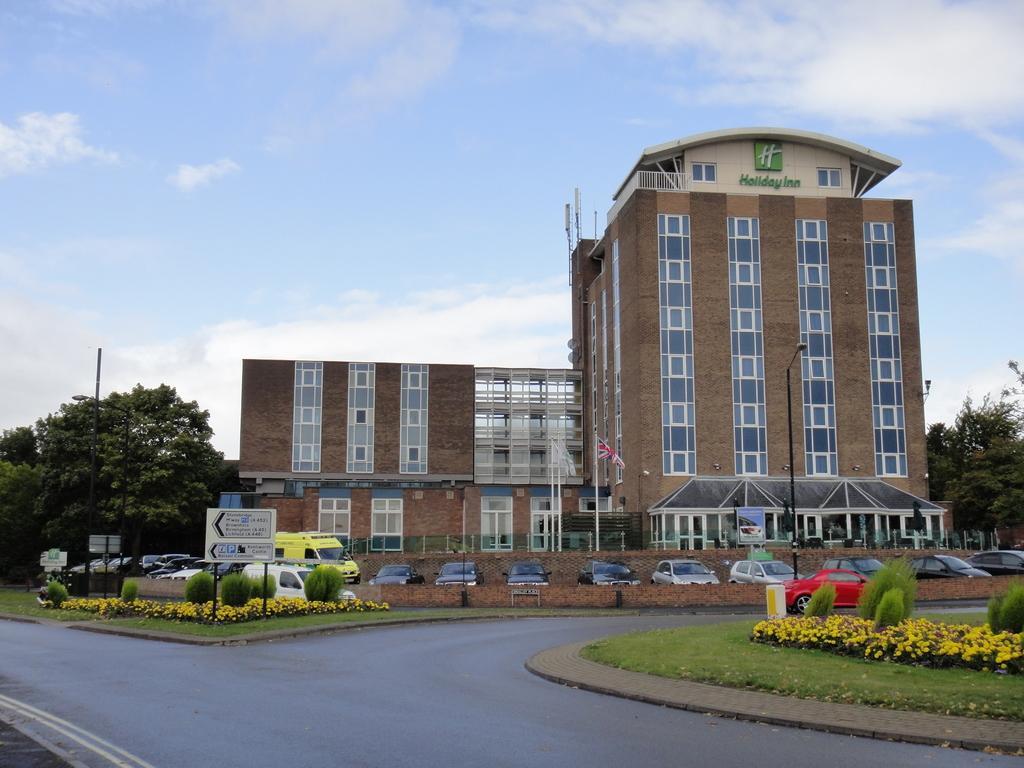In one or two sentences, can you explain what this image depicts? In this image we can see a building. On the building we can see the windows and some text. In front of the building we can see vehicles, grass, plants, flowers, boards with text, a pole with a flag and street pole. On both sides of the image we can see the trees. At the top we can see the sky. 